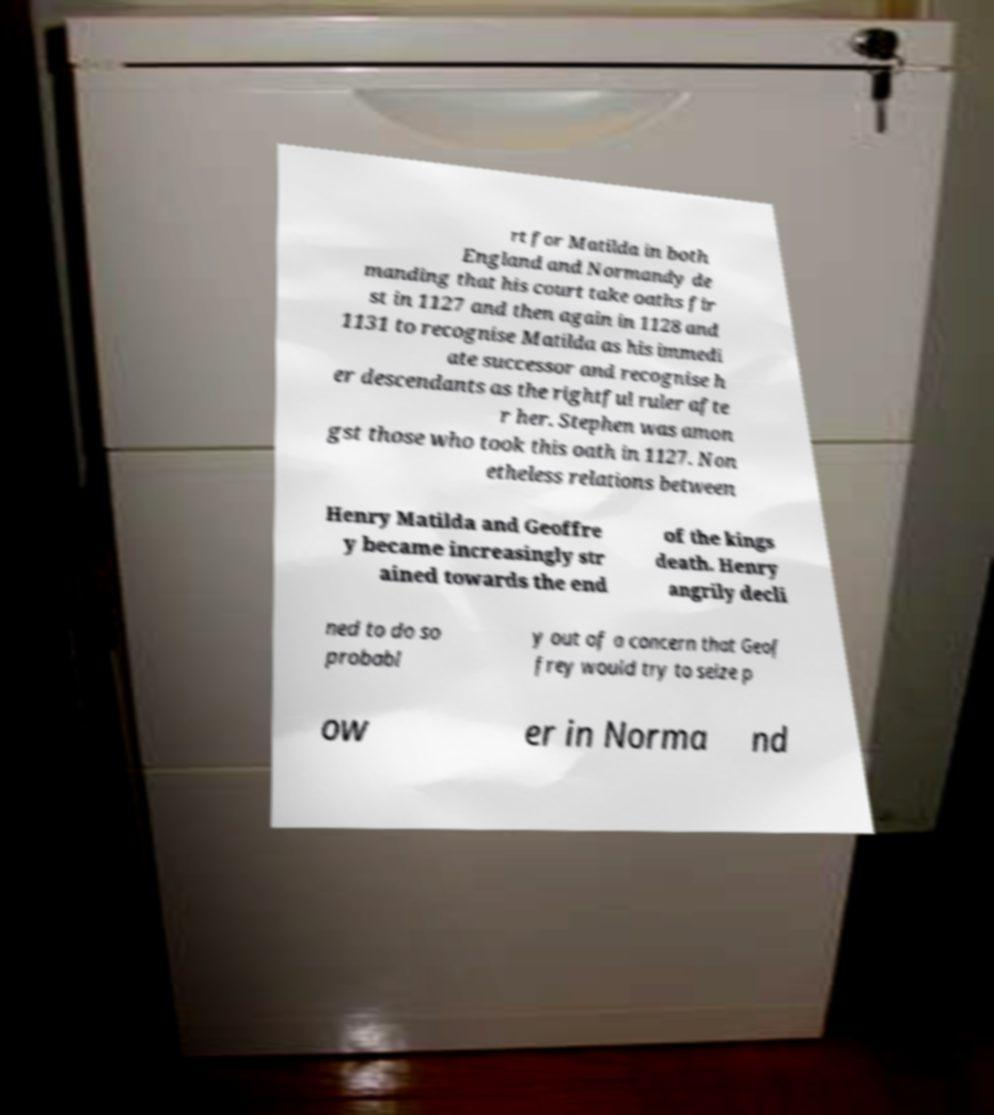Can you read and provide the text displayed in the image?This photo seems to have some interesting text. Can you extract and type it out for me? rt for Matilda in both England and Normandy de manding that his court take oaths fir st in 1127 and then again in 1128 and 1131 to recognise Matilda as his immedi ate successor and recognise h er descendants as the rightful ruler afte r her. Stephen was amon gst those who took this oath in 1127. Non etheless relations between Henry Matilda and Geoffre y became increasingly str ained towards the end of the kings death. Henry angrily decli ned to do so probabl y out of a concern that Geof frey would try to seize p ow er in Norma nd 